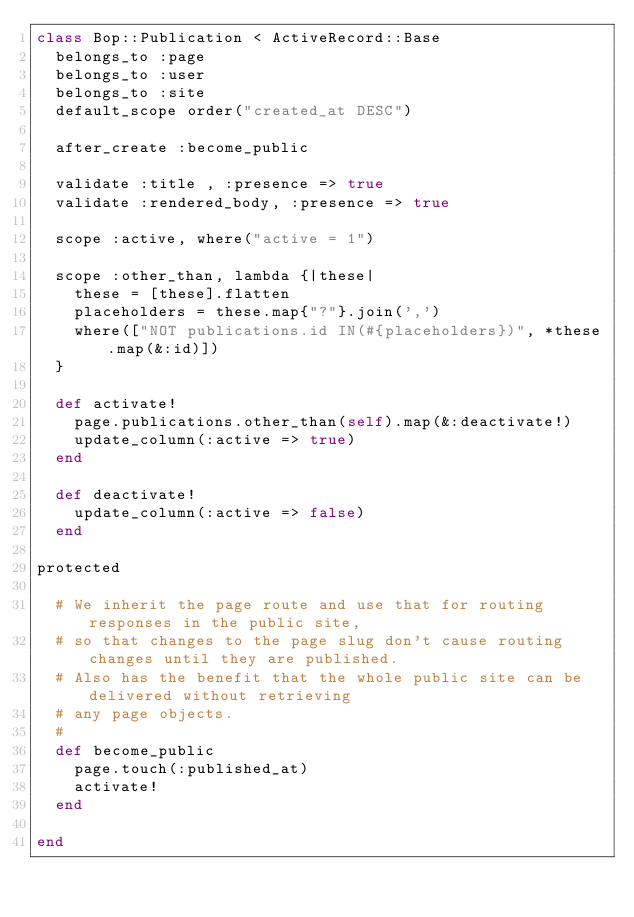<code> <loc_0><loc_0><loc_500><loc_500><_Ruby_>class Bop::Publication < ActiveRecord::Base
  belongs_to :page
  belongs_to :user
  belongs_to :site
  default_scope order("created_at DESC")

  after_create :become_public

  validate :title , :presence => true
  validate :rendered_body, :presence => true

  scope :active, where("active = 1")

  scope :other_than, lambda {|these|
    these = [these].flatten
    placeholders = these.map{"?"}.join(',')
    where(["NOT publications.id IN(#{placeholders})", *these.map(&:id)])
  }

  def activate!
    page.publications.other_than(self).map(&:deactivate!)
    update_column(:active => true)
  end
  
  def deactivate!
    update_column(:active => false)
  end

protected

  # We inherit the page route and use that for routing responses in the public site,
  # so that changes to the page slug don't cause routing changes until they are published.
  # Also has the benefit that the whole public site can be delivered without retrieving
  # any page objects.
  #
  def become_public
    page.touch(:published_at)
    activate!
  end
  
end
</code> 